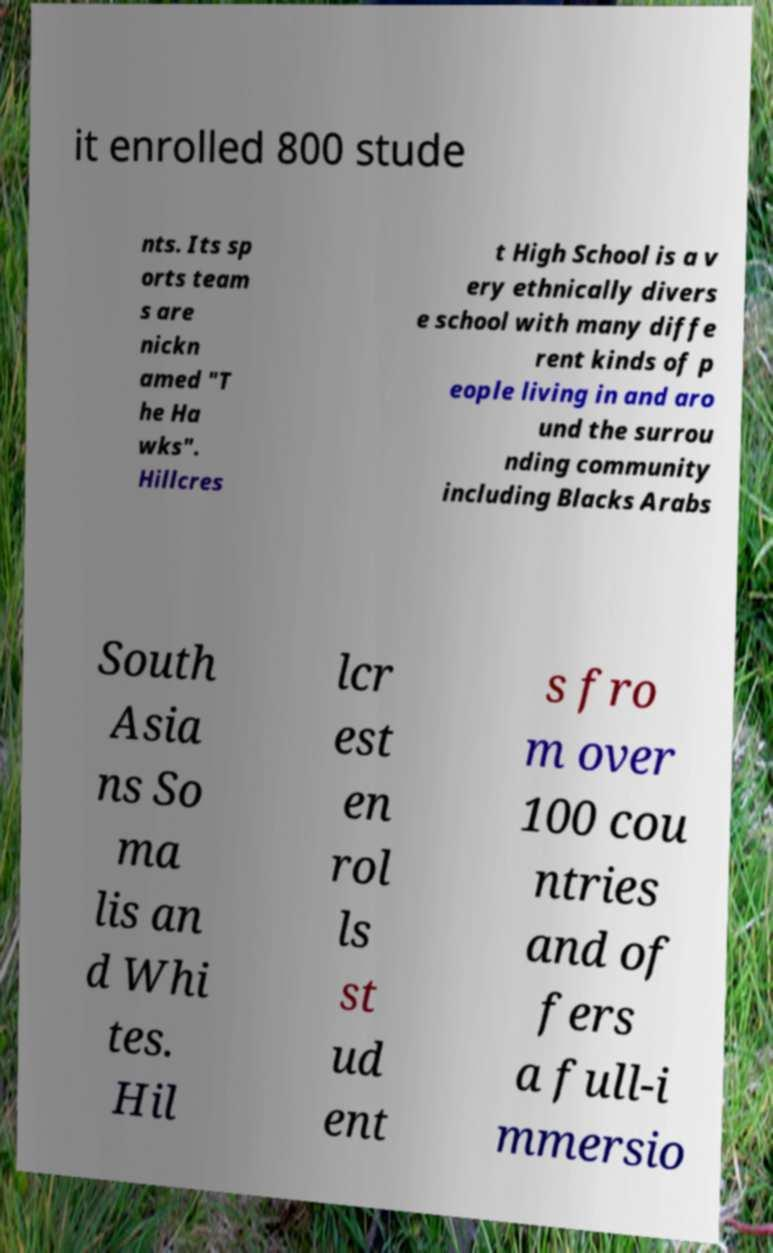What messages or text are displayed in this image? I need them in a readable, typed format. it enrolled 800 stude nts. Its sp orts team s are nickn amed "T he Ha wks". Hillcres t High School is a v ery ethnically divers e school with many diffe rent kinds of p eople living in and aro und the surrou nding community including Blacks Arabs South Asia ns So ma lis an d Whi tes. Hil lcr est en rol ls st ud ent s fro m over 100 cou ntries and of fers a full-i mmersio 